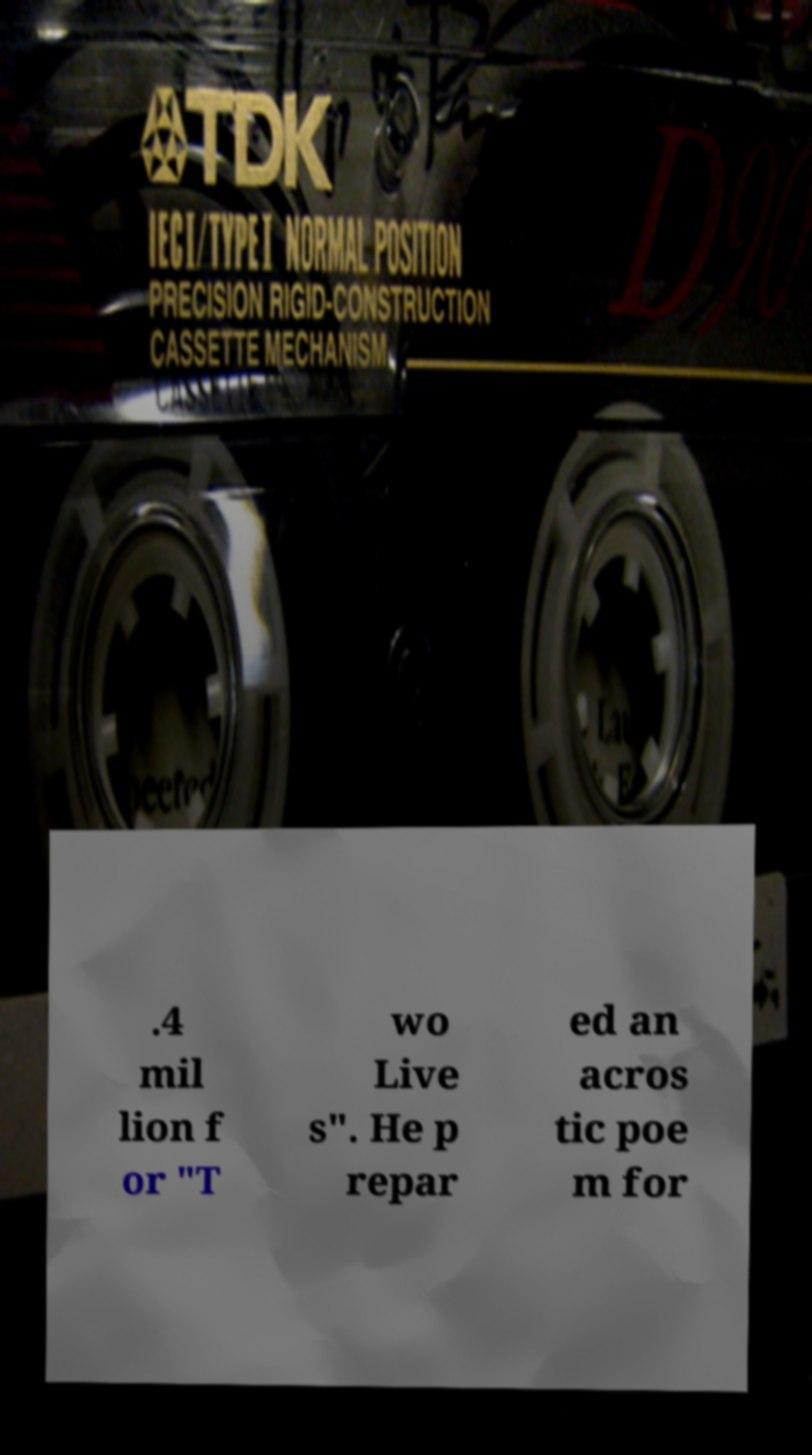Please identify and transcribe the text found in this image. .4 mil lion f or "T wo Live s". He p repar ed an acros tic poe m for 